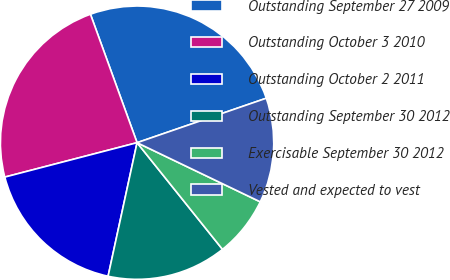<chart> <loc_0><loc_0><loc_500><loc_500><pie_chart><fcel>Outstanding September 27 2009<fcel>Outstanding October 3 2010<fcel>Outstanding October 2 2011<fcel>Outstanding September 30 2012<fcel>Exercisable September 30 2012<fcel>Vested and expected to vest<nl><fcel>25.27%<fcel>23.51%<fcel>17.55%<fcel>14.15%<fcel>7.13%<fcel>12.4%<nl></chart> 